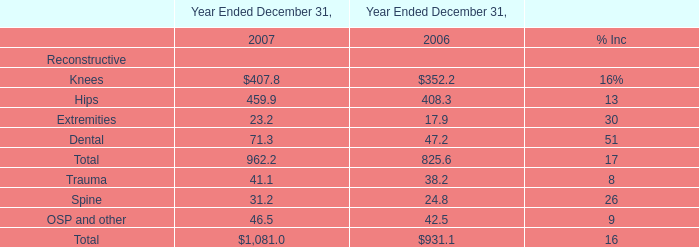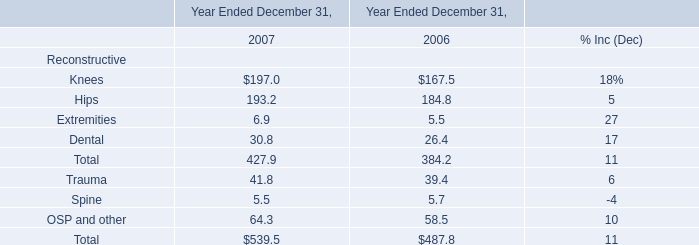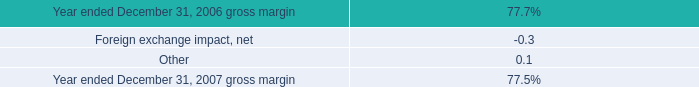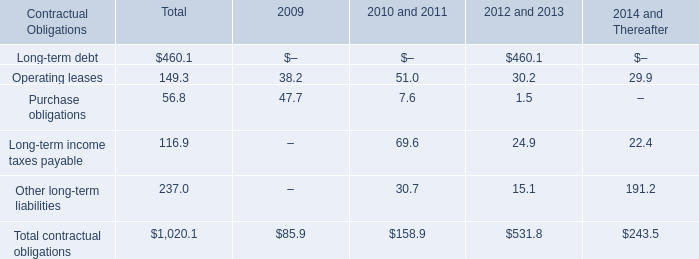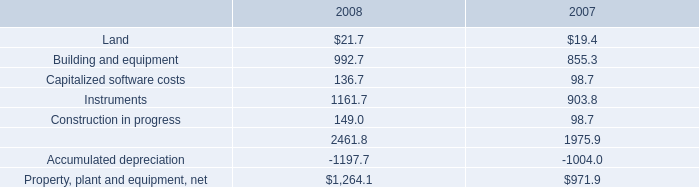What's the sum of all 2008 that are greater than1000 in 2008? 
Computations: (1161.7 + 2461.8)
Answer: 3623.5. 